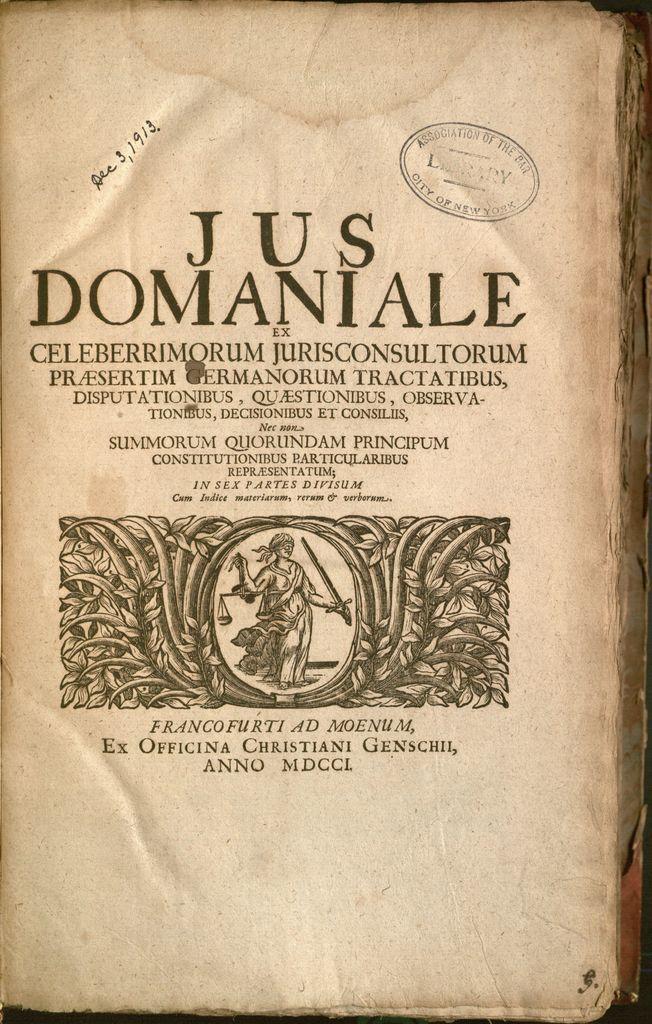What is the name of the book?
Your response must be concise. Jus domaniale. Is this book written in latin?
Your answer should be compact. Yes. 